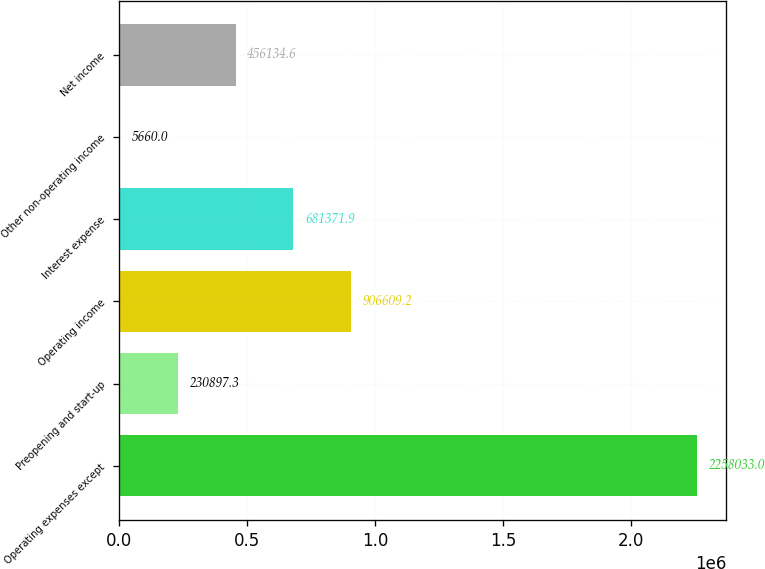Convert chart to OTSL. <chart><loc_0><loc_0><loc_500><loc_500><bar_chart><fcel>Operating expenses except<fcel>Preopening and start-up<fcel>Operating income<fcel>Interest expense<fcel>Other non-operating income<fcel>Net income<nl><fcel>2.25803e+06<fcel>230897<fcel>906609<fcel>681372<fcel>5660<fcel>456135<nl></chart> 